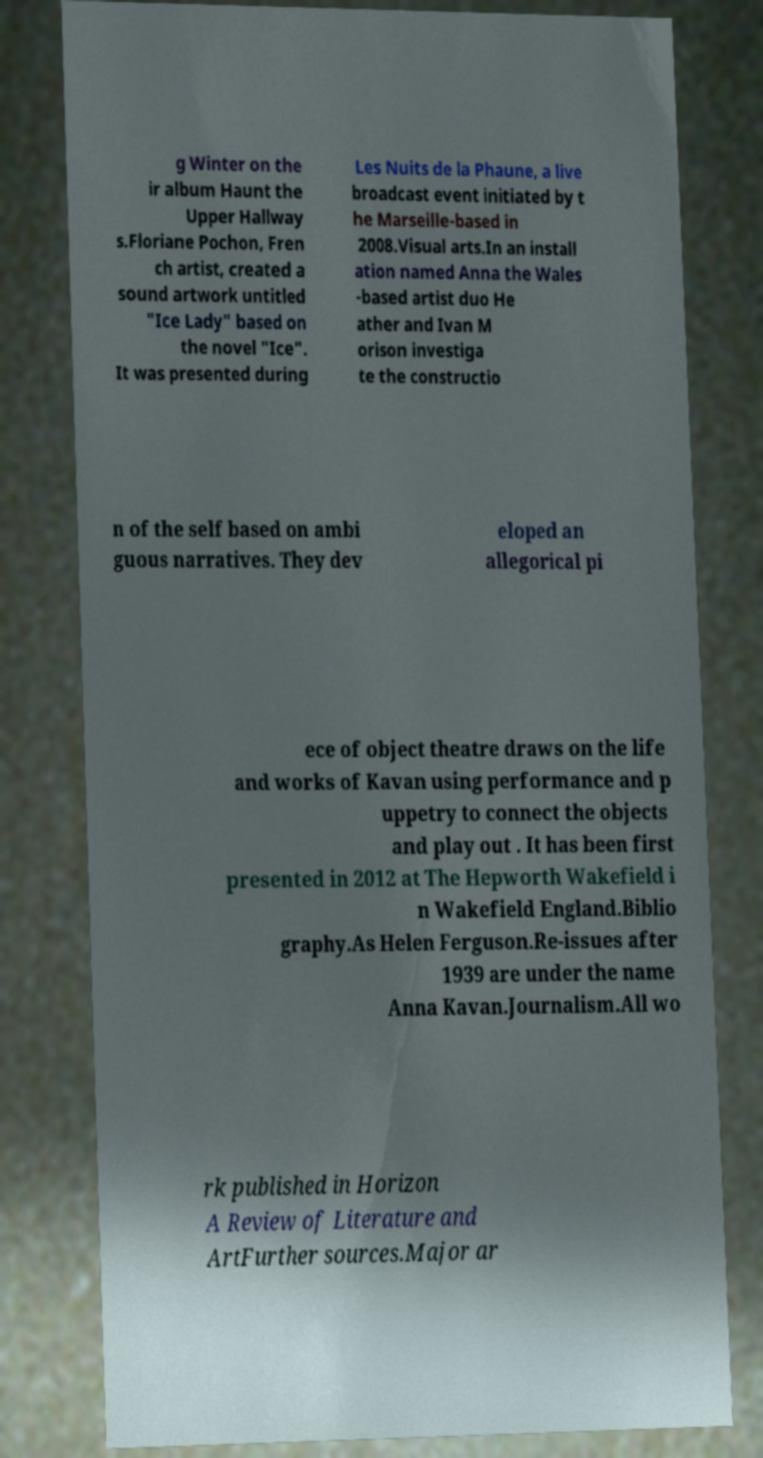Please identify and transcribe the text found in this image. g Winter on the ir album Haunt the Upper Hallway s.Floriane Pochon, Fren ch artist, created a sound artwork untitled "Ice Lady" based on the novel "Ice". It was presented during Les Nuits de la Phaune, a live broadcast event initiated by t he Marseille-based in 2008.Visual arts.In an install ation named Anna the Wales -based artist duo He ather and Ivan M orison investiga te the constructio n of the self based on ambi guous narratives. They dev eloped an allegorical pi ece of object theatre draws on the life and works of Kavan using performance and p uppetry to connect the objects and play out . It has been first presented in 2012 at The Hepworth Wakefield i n Wakefield England.Biblio graphy.As Helen Ferguson.Re-issues after 1939 are under the name Anna Kavan.Journalism.All wo rk published in Horizon A Review of Literature and ArtFurther sources.Major ar 